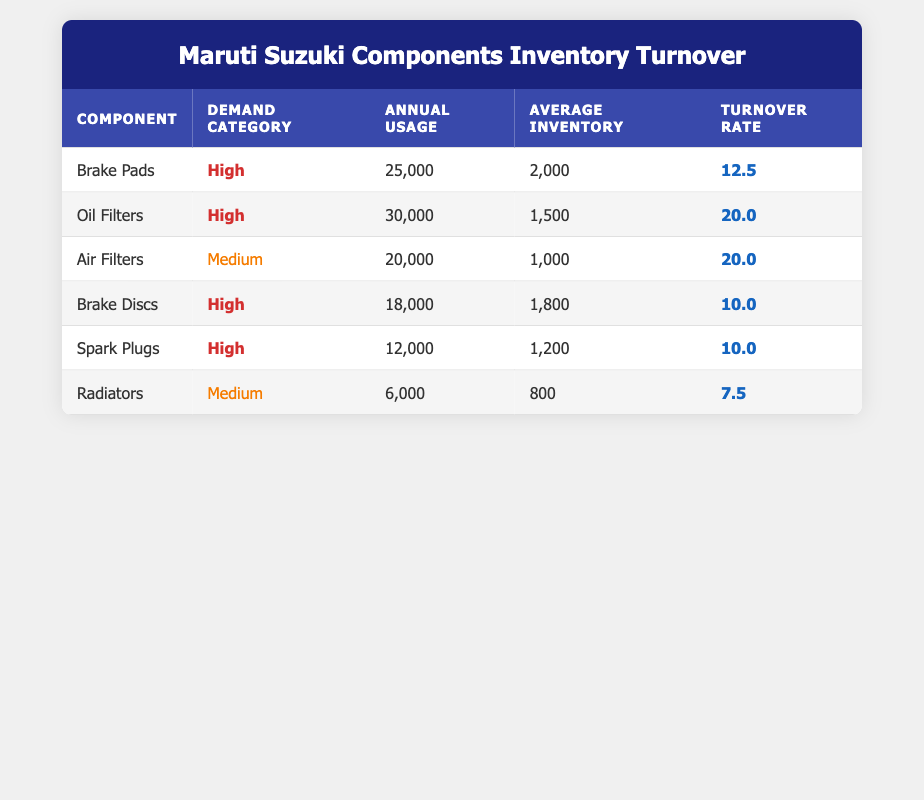What is the annual usage for Oil Filters? The table shows that the annual usage for Oil Filters is listed directly in the corresponding row. It states 30,000.
Answer: 30,000 What is the turnover rate of Brake Pads? The turnover rate for Brake Pads is provided in the table under the "Turnover Rate" column for that component, which is 12.5.
Answer: 12.5 Which component has the highest annual usage? To determine which component has the highest annual usage, I review the 'Annual Usage' column and find that Oil Filters have the highest value at 30,000.
Answer: Oil Filters Is the demand for Spark Plugs categorized as High? Checking the demand category for Spark Plugs in the table, it is labeled as High in the corresponding row for that component.
Answer: Yes What is the average turnover rate for High demand components? I identify the components with High demand: Brake Pads (12.5), Oil Filters (20.0), Brake Discs (10.0), and Spark Plugs (10.0). I calculate the average: (12.5 + 20.0 + 10.0 + 10.0) / 4 = 13.75.
Answer: 13.75 Which component has the lowest turnover rate and what is its value? I review each component's turnover rate to determine the lowest. Radiators have a turnover rate of 7.5, which is the lowest among all components listed.
Answer: Radiators, 7.5 Are there any components with a turnover rate of more than 15? I check the "Turnover Rate" column for values greater than 15. I find that Oil Filters (20.0) meets this criterion, while the others do not.
Answer: Yes If the average inventory of the Air Filters is increased to 1,200, what will be the new turnover rate? The turnover rate is calculated by dividing the annual usage by average inventory. With the annual usage of 20,000 remaining and average inventory at 1,200: 20,000 / 1,200 = 16.67. Therefore, the new turnover rate would be approximately 16.67.
Answer: 16.67 What demand category does the component Radiators fall under? By reviewing the demand category listed in the table, I can see that for Radiators, it is listed as Medium.
Answer: Medium 